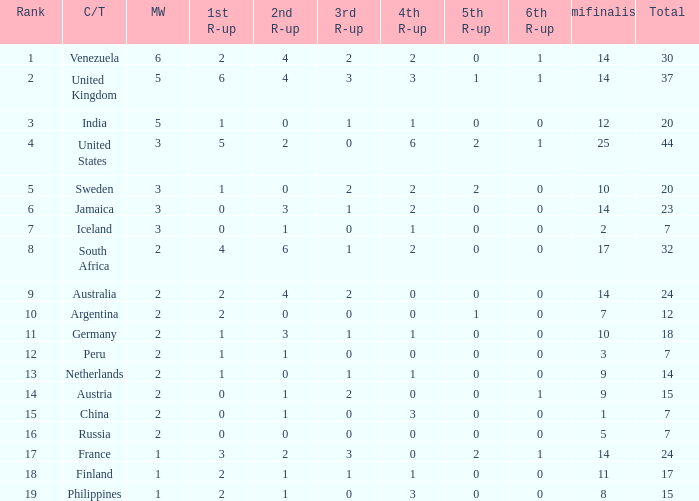Which countries have a 5th runner-up ranking is 2 and the 3rd runner-up ranking is 0 44.0. 